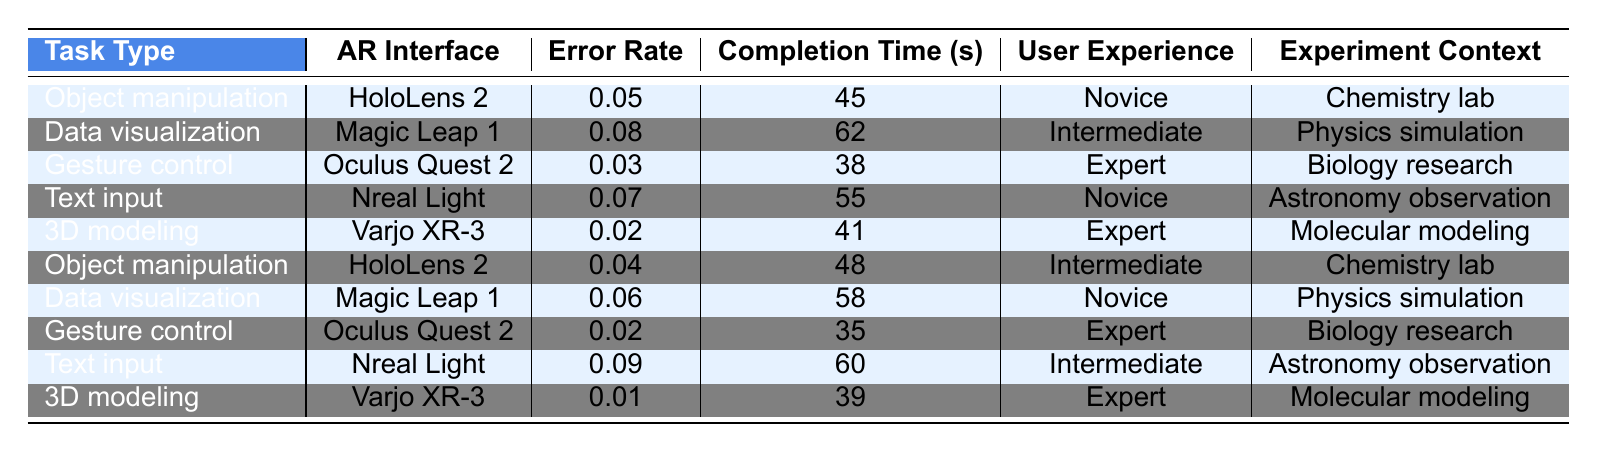What is the error rate for 3D modeling using the Varjo XR-3? From the table, the error rate for 3D modeling with the Varjo XR-3 is listed as 0.02.
Answer: 0.02 Which AR interface has the highest completion time for the task of Data visualization? The task of Data visualization using the Magic Leap 1 has the highest completion time, which is 62 seconds.
Answer: 62 seconds Is the error rate for Gesture control with the Oculus Quest 2 higher than 0.05? The error rate for Gesture control with the Oculus Quest 2 is 0.03, which is less than 0.05. Therefore, the statement is false.
Answer: No What is the average completion time for all tasks using HoloLens 2? For HoloLens 2, the completion times are 45 seconds (Object manipulation) and 48 seconds (Object manipulation). The average is (45 + 48) / 2 = 46.5 seconds.
Answer: 46.5 seconds Which task type has the lowest error rate when using Nreal Light? When using Nreal Light for tasks, the error rates are 0.07 (Text input) and 0.09 (Text input). The lowest error rate is 0.07.
Answer: 0.07 Are there any expert users with a completion time less than 40 seconds in the table? The only expert users with completion times listed are for Gesture control (35 seconds) and 3D modeling (39 seconds). Since there are expert users with completion times less than 40 seconds, the answer is yes.
Answer: Yes What is the difference in error rates between Data visualization on Magic Leap 1 and Object manipulation on HoloLens 2? The error rate for Data visualization on Magic Leap 1 is 0.08, and for Object manipulation on HoloLens 2, it is 0.05. The difference is 0.08 - 0.05 = 0.03.
Answer: 0.03 What is the total completion time for all tasks performed using the Varjo XR-3? The completion times for 3D modeling with Varjo XR-3 are recorded as 41 seconds (first instance) and 39 seconds (second instance). Adding these gives a total of 41 + 39 = 80 seconds.
Answer: 80 seconds Which task has the highest error rate, and what is that error rate? The task with the highest error rate is Data visualization on Magic Leap 1, with an error rate of 0.08.
Answer: 0.08 Is the user experience level for Object manipulation tasks solely comprised of Novice users? Object manipulation tasks include users with varying experience levels: Novice and Intermediate for HoloLens 2, and an expert user for the second Object manipulation. Therefore, it is false that all are novices.
Answer: No 